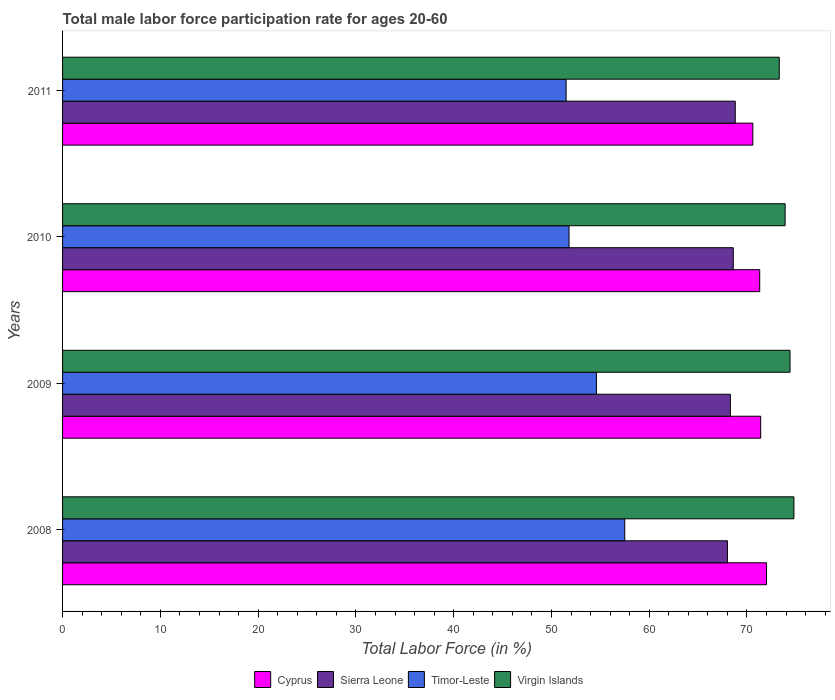How many groups of bars are there?
Ensure brevity in your answer.  4. How many bars are there on the 3rd tick from the top?
Your answer should be very brief. 4. What is the label of the 4th group of bars from the top?
Give a very brief answer. 2008. In how many cases, is the number of bars for a given year not equal to the number of legend labels?
Your answer should be compact. 0. Across all years, what is the maximum male labor force participation rate in Timor-Leste?
Your response must be concise. 57.5. Across all years, what is the minimum male labor force participation rate in Timor-Leste?
Offer a terse response. 51.5. In which year was the male labor force participation rate in Sierra Leone minimum?
Provide a short and direct response. 2008. What is the total male labor force participation rate in Sierra Leone in the graph?
Offer a very short reply. 273.7. What is the difference between the male labor force participation rate in Timor-Leste in 2008 and that in 2010?
Provide a succinct answer. 5.7. What is the difference between the male labor force participation rate in Timor-Leste in 2010 and the male labor force participation rate in Virgin Islands in 2011?
Offer a terse response. -21.5. What is the average male labor force participation rate in Virgin Islands per year?
Offer a very short reply. 74.1. In the year 2009, what is the difference between the male labor force participation rate in Virgin Islands and male labor force participation rate in Cyprus?
Your answer should be compact. 3. In how many years, is the male labor force participation rate in Sierra Leone greater than 50 %?
Your answer should be very brief. 4. What is the ratio of the male labor force participation rate in Sierra Leone in 2010 to that in 2011?
Your response must be concise. 1. Is the male labor force participation rate in Virgin Islands in 2008 less than that in 2009?
Your answer should be compact. No. Is the difference between the male labor force participation rate in Virgin Islands in 2008 and 2010 greater than the difference between the male labor force participation rate in Cyprus in 2008 and 2010?
Your answer should be compact. Yes. What is the difference between the highest and the second highest male labor force participation rate in Virgin Islands?
Offer a terse response. 0.4. What is the difference between the highest and the lowest male labor force participation rate in Cyprus?
Provide a short and direct response. 1.4. In how many years, is the male labor force participation rate in Sierra Leone greater than the average male labor force participation rate in Sierra Leone taken over all years?
Offer a terse response. 2. Is the sum of the male labor force participation rate in Cyprus in 2008 and 2011 greater than the maximum male labor force participation rate in Virgin Islands across all years?
Offer a very short reply. Yes. What does the 4th bar from the top in 2011 represents?
Provide a short and direct response. Cyprus. What does the 3rd bar from the bottom in 2009 represents?
Offer a very short reply. Timor-Leste. How many bars are there?
Offer a very short reply. 16. What is the difference between two consecutive major ticks on the X-axis?
Provide a succinct answer. 10. Are the values on the major ticks of X-axis written in scientific E-notation?
Make the answer very short. No. Does the graph contain grids?
Make the answer very short. No. How many legend labels are there?
Ensure brevity in your answer.  4. What is the title of the graph?
Ensure brevity in your answer.  Total male labor force participation rate for ages 20-60. What is the label or title of the X-axis?
Provide a short and direct response. Total Labor Force (in %). What is the label or title of the Y-axis?
Your answer should be very brief. Years. What is the Total Labor Force (in %) of Cyprus in 2008?
Your answer should be very brief. 72. What is the Total Labor Force (in %) in Sierra Leone in 2008?
Provide a short and direct response. 68. What is the Total Labor Force (in %) of Timor-Leste in 2008?
Your answer should be very brief. 57.5. What is the Total Labor Force (in %) in Virgin Islands in 2008?
Keep it short and to the point. 74.8. What is the Total Labor Force (in %) in Cyprus in 2009?
Your answer should be compact. 71.4. What is the Total Labor Force (in %) of Sierra Leone in 2009?
Make the answer very short. 68.3. What is the Total Labor Force (in %) in Timor-Leste in 2009?
Ensure brevity in your answer.  54.6. What is the Total Labor Force (in %) of Virgin Islands in 2009?
Ensure brevity in your answer.  74.4. What is the Total Labor Force (in %) in Cyprus in 2010?
Keep it short and to the point. 71.3. What is the Total Labor Force (in %) in Sierra Leone in 2010?
Offer a very short reply. 68.6. What is the Total Labor Force (in %) in Timor-Leste in 2010?
Provide a succinct answer. 51.8. What is the Total Labor Force (in %) in Virgin Islands in 2010?
Ensure brevity in your answer.  73.9. What is the Total Labor Force (in %) in Cyprus in 2011?
Offer a very short reply. 70.6. What is the Total Labor Force (in %) in Sierra Leone in 2011?
Ensure brevity in your answer.  68.8. What is the Total Labor Force (in %) in Timor-Leste in 2011?
Your response must be concise. 51.5. What is the Total Labor Force (in %) in Virgin Islands in 2011?
Offer a very short reply. 73.3. Across all years, what is the maximum Total Labor Force (in %) in Cyprus?
Your answer should be very brief. 72. Across all years, what is the maximum Total Labor Force (in %) of Sierra Leone?
Provide a short and direct response. 68.8. Across all years, what is the maximum Total Labor Force (in %) of Timor-Leste?
Your answer should be compact. 57.5. Across all years, what is the maximum Total Labor Force (in %) in Virgin Islands?
Offer a very short reply. 74.8. Across all years, what is the minimum Total Labor Force (in %) of Cyprus?
Your answer should be compact. 70.6. Across all years, what is the minimum Total Labor Force (in %) of Timor-Leste?
Your answer should be very brief. 51.5. Across all years, what is the minimum Total Labor Force (in %) of Virgin Islands?
Your response must be concise. 73.3. What is the total Total Labor Force (in %) of Cyprus in the graph?
Provide a succinct answer. 285.3. What is the total Total Labor Force (in %) of Sierra Leone in the graph?
Your answer should be compact. 273.7. What is the total Total Labor Force (in %) of Timor-Leste in the graph?
Provide a short and direct response. 215.4. What is the total Total Labor Force (in %) of Virgin Islands in the graph?
Make the answer very short. 296.4. What is the difference between the Total Labor Force (in %) of Sierra Leone in 2008 and that in 2010?
Your answer should be compact. -0.6. What is the difference between the Total Labor Force (in %) of Timor-Leste in 2008 and that in 2010?
Make the answer very short. 5.7. What is the difference between the Total Labor Force (in %) in Virgin Islands in 2008 and that in 2010?
Offer a very short reply. 0.9. What is the difference between the Total Labor Force (in %) in Cyprus in 2008 and that in 2011?
Make the answer very short. 1.4. What is the difference between the Total Labor Force (in %) of Sierra Leone in 2008 and that in 2011?
Ensure brevity in your answer.  -0.8. What is the difference between the Total Labor Force (in %) in Timor-Leste in 2008 and that in 2011?
Your answer should be compact. 6. What is the difference between the Total Labor Force (in %) in Virgin Islands in 2008 and that in 2011?
Ensure brevity in your answer.  1.5. What is the difference between the Total Labor Force (in %) in Sierra Leone in 2009 and that in 2010?
Keep it short and to the point. -0.3. What is the difference between the Total Labor Force (in %) of Cyprus in 2009 and that in 2011?
Give a very brief answer. 0.8. What is the difference between the Total Labor Force (in %) of Virgin Islands in 2009 and that in 2011?
Provide a short and direct response. 1.1. What is the difference between the Total Labor Force (in %) of Sierra Leone in 2010 and that in 2011?
Provide a short and direct response. -0.2. What is the difference between the Total Labor Force (in %) of Timor-Leste in 2010 and that in 2011?
Offer a very short reply. 0.3. What is the difference between the Total Labor Force (in %) in Cyprus in 2008 and the Total Labor Force (in %) in Timor-Leste in 2009?
Your answer should be compact. 17.4. What is the difference between the Total Labor Force (in %) of Timor-Leste in 2008 and the Total Labor Force (in %) of Virgin Islands in 2009?
Give a very brief answer. -16.9. What is the difference between the Total Labor Force (in %) in Cyprus in 2008 and the Total Labor Force (in %) in Timor-Leste in 2010?
Your response must be concise. 20.2. What is the difference between the Total Labor Force (in %) of Cyprus in 2008 and the Total Labor Force (in %) of Virgin Islands in 2010?
Your response must be concise. -1.9. What is the difference between the Total Labor Force (in %) in Timor-Leste in 2008 and the Total Labor Force (in %) in Virgin Islands in 2010?
Offer a terse response. -16.4. What is the difference between the Total Labor Force (in %) of Cyprus in 2008 and the Total Labor Force (in %) of Sierra Leone in 2011?
Give a very brief answer. 3.2. What is the difference between the Total Labor Force (in %) of Cyprus in 2008 and the Total Labor Force (in %) of Timor-Leste in 2011?
Give a very brief answer. 20.5. What is the difference between the Total Labor Force (in %) in Timor-Leste in 2008 and the Total Labor Force (in %) in Virgin Islands in 2011?
Offer a very short reply. -15.8. What is the difference between the Total Labor Force (in %) of Cyprus in 2009 and the Total Labor Force (in %) of Sierra Leone in 2010?
Provide a short and direct response. 2.8. What is the difference between the Total Labor Force (in %) of Cyprus in 2009 and the Total Labor Force (in %) of Timor-Leste in 2010?
Provide a short and direct response. 19.6. What is the difference between the Total Labor Force (in %) of Sierra Leone in 2009 and the Total Labor Force (in %) of Virgin Islands in 2010?
Provide a short and direct response. -5.6. What is the difference between the Total Labor Force (in %) in Timor-Leste in 2009 and the Total Labor Force (in %) in Virgin Islands in 2010?
Your answer should be very brief. -19.3. What is the difference between the Total Labor Force (in %) of Cyprus in 2009 and the Total Labor Force (in %) of Virgin Islands in 2011?
Provide a succinct answer. -1.9. What is the difference between the Total Labor Force (in %) of Sierra Leone in 2009 and the Total Labor Force (in %) of Timor-Leste in 2011?
Your response must be concise. 16.8. What is the difference between the Total Labor Force (in %) in Sierra Leone in 2009 and the Total Labor Force (in %) in Virgin Islands in 2011?
Your answer should be very brief. -5. What is the difference between the Total Labor Force (in %) of Timor-Leste in 2009 and the Total Labor Force (in %) of Virgin Islands in 2011?
Make the answer very short. -18.7. What is the difference between the Total Labor Force (in %) of Cyprus in 2010 and the Total Labor Force (in %) of Sierra Leone in 2011?
Your response must be concise. 2.5. What is the difference between the Total Labor Force (in %) in Cyprus in 2010 and the Total Labor Force (in %) in Timor-Leste in 2011?
Your answer should be very brief. 19.8. What is the difference between the Total Labor Force (in %) of Cyprus in 2010 and the Total Labor Force (in %) of Virgin Islands in 2011?
Provide a short and direct response. -2. What is the difference between the Total Labor Force (in %) of Sierra Leone in 2010 and the Total Labor Force (in %) of Virgin Islands in 2011?
Give a very brief answer. -4.7. What is the difference between the Total Labor Force (in %) of Timor-Leste in 2010 and the Total Labor Force (in %) of Virgin Islands in 2011?
Provide a succinct answer. -21.5. What is the average Total Labor Force (in %) in Cyprus per year?
Offer a very short reply. 71.33. What is the average Total Labor Force (in %) of Sierra Leone per year?
Offer a terse response. 68.42. What is the average Total Labor Force (in %) in Timor-Leste per year?
Provide a short and direct response. 53.85. What is the average Total Labor Force (in %) of Virgin Islands per year?
Your answer should be very brief. 74.1. In the year 2008, what is the difference between the Total Labor Force (in %) in Cyprus and Total Labor Force (in %) in Sierra Leone?
Give a very brief answer. 4. In the year 2008, what is the difference between the Total Labor Force (in %) of Cyprus and Total Labor Force (in %) of Timor-Leste?
Provide a short and direct response. 14.5. In the year 2008, what is the difference between the Total Labor Force (in %) in Cyprus and Total Labor Force (in %) in Virgin Islands?
Give a very brief answer. -2.8. In the year 2008, what is the difference between the Total Labor Force (in %) in Timor-Leste and Total Labor Force (in %) in Virgin Islands?
Make the answer very short. -17.3. In the year 2009, what is the difference between the Total Labor Force (in %) in Cyprus and Total Labor Force (in %) in Sierra Leone?
Ensure brevity in your answer.  3.1. In the year 2009, what is the difference between the Total Labor Force (in %) of Cyprus and Total Labor Force (in %) of Virgin Islands?
Your response must be concise. -3. In the year 2009, what is the difference between the Total Labor Force (in %) in Timor-Leste and Total Labor Force (in %) in Virgin Islands?
Offer a very short reply. -19.8. In the year 2010, what is the difference between the Total Labor Force (in %) of Cyprus and Total Labor Force (in %) of Sierra Leone?
Offer a very short reply. 2.7. In the year 2010, what is the difference between the Total Labor Force (in %) of Cyprus and Total Labor Force (in %) of Timor-Leste?
Give a very brief answer. 19.5. In the year 2010, what is the difference between the Total Labor Force (in %) in Timor-Leste and Total Labor Force (in %) in Virgin Islands?
Give a very brief answer. -22.1. In the year 2011, what is the difference between the Total Labor Force (in %) of Cyprus and Total Labor Force (in %) of Timor-Leste?
Provide a succinct answer. 19.1. In the year 2011, what is the difference between the Total Labor Force (in %) of Timor-Leste and Total Labor Force (in %) of Virgin Islands?
Offer a terse response. -21.8. What is the ratio of the Total Labor Force (in %) in Cyprus in 2008 to that in 2009?
Offer a terse response. 1.01. What is the ratio of the Total Labor Force (in %) in Sierra Leone in 2008 to that in 2009?
Offer a terse response. 1. What is the ratio of the Total Labor Force (in %) in Timor-Leste in 2008 to that in 2009?
Your response must be concise. 1.05. What is the ratio of the Total Labor Force (in %) of Virgin Islands in 2008 to that in 2009?
Your answer should be compact. 1.01. What is the ratio of the Total Labor Force (in %) in Cyprus in 2008 to that in 2010?
Offer a very short reply. 1.01. What is the ratio of the Total Labor Force (in %) in Sierra Leone in 2008 to that in 2010?
Provide a succinct answer. 0.99. What is the ratio of the Total Labor Force (in %) of Timor-Leste in 2008 to that in 2010?
Provide a short and direct response. 1.11. What is the ratio of the Total Labor Force (in %) of Virgin Islands in 2008 to that in 2010?
Offer a terse response. 1.01. What is the ratio of the Total Labor Force (in %) in Cyprus in 2008 to that in 2011?
Provide a short and direct response. 1.02. What is the ratio of the Total Labor Force (in %) of Sierra Leone in 2008 to that in 2011?
Make the answer very short. 0.99. What is the ratio of the Total Labor Force (in %) in Timor-Leste in 2008 to that in 2011?
Provide a succinct answer. 1.12. What is the ratio of the Total Labor Force (in %) of Virgin Islands in 2008 to that in 2011?
Offer a terse response. 1.02. What is the ratio of the Total Labor Force (in %) in Cyprus in 2009 to that in 2010?
Your response must be concise. 1. What is the ratio of the Total Labor Force (in %) of Sierra Leone in 2009 to that in 2010?
Your response must be concise. 1. What is the ratio of the Total Labor Force (in %) in Timor-Leste in 2009 to that in 2010?
Make the answer very short. 1.05. What is the ratio of the Total Labor Force (in %) in Virgin Islands in 2009 to that in 2010?
Keep it short and to the point. 1.01. What is the ratio of the Total Labor Force (in %) of Cyprus in 2009 to that in 2011?
Give a very brief answer. 1.01. What is the ratio of the Total Labor Force (in %) in Timor-Leste in 2009 to that in 2011?
Keep it short and to the point. 1.06. What is the ratio of the Total Labor Force (in %) of Cyprus in 2010 to that in 2011?
Your response must be concise. 1.01. What is the ratio of the Total Labor Force (in %) of Sierra Leone in 2010 to that in 2011?
Ensure brevity in your answer.  1. What is the ratio of the Total Labor Force (in %) of Timor-Leste in 2010 to that in 2011?
Your answer should be compact. 1.01. What is the ratio of the Total Labor Force (in %) of Virgin Islands in 2010 to that in 2011?
Keep it short and to the point. 1.01. What is the difference between the highest and the second highest Total Labor Force (in %) in Timor-Leste?
Give a very brief answer. 2.9. What is the difference between the highest and the second highest Total Labor Force (in %) of Virgin Islands?
Make the answer very short. 0.4. What is the difference between the highest and the lowest Total Labor Force (in %) of Cyprus?
Keep it short and to the point. 1.4. What is the difference between the highest and the lowest Total Labor Force (in %) of Timor-Leste?
Ensure brevity in your answer.  6. 